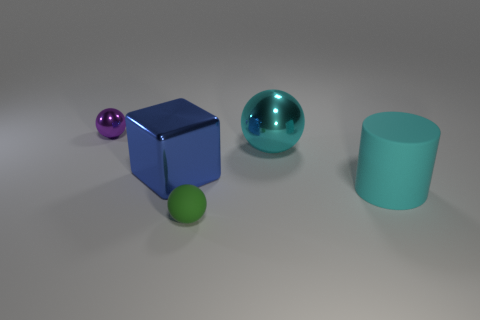Add 1 cylinders. How many objects exist? 6 Subtract all balls. How many objects are left? 2 Add 3 big rubber cylinders. How many big rubber cylinders exist? 4 Subtract 0 gray cubes. How many objects are left? 5 Subtract all big gray metal spheres. Subtract all large cyan balls. How many objects are left? 4 Add 2 tiny purple things. How many tiny purple things are left? 3 